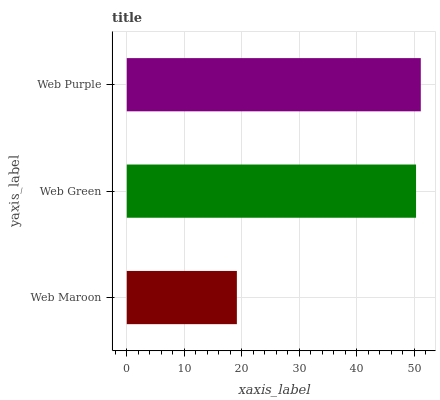Is Web Maroon the minimum?
Answer yes or no. Yes. Is Web Purple the maximum?
Answer yes or no. Yes. Is Web Green the minimum?
Answer yes or no. No. Is Web Green the maximum?
Answer yes or no. No. Is Web Green greater than Web Maroon?
Answer yes or no. Yes. Is Web Maroon less than Web Green?
Answer yes or no. Yes. Is Web Maroon greater than Web Green?
Answer yes or no. No. Is Web Green less than Web Maroon?
Answer yes or no. No. Is Web Green the high median?
Answer yes or no. Yes. Is Web Green the low median?
Answer yes or no. Yes. Is Web Purple the high median?
Answer yes or no. No. Is Web Maroon the low median?
Answer yes or no. No. 